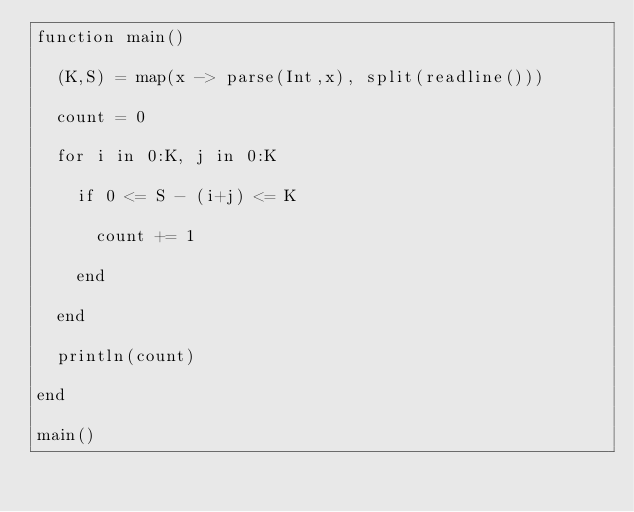Convert code to text. <code><loc_0><loc_0><loc_500><loc_500><_Julia_>function main()
  
  (K,S) = map(x -> parse(Int,x), split(readline()))
  
  count = 0
  
  for i in 0:K, j in 0:K
    
    if 0 <= S - (i+j) <= K
      
      count += 1
      
    end
    
  end
  
  println(count)
  
end

main()</code> 